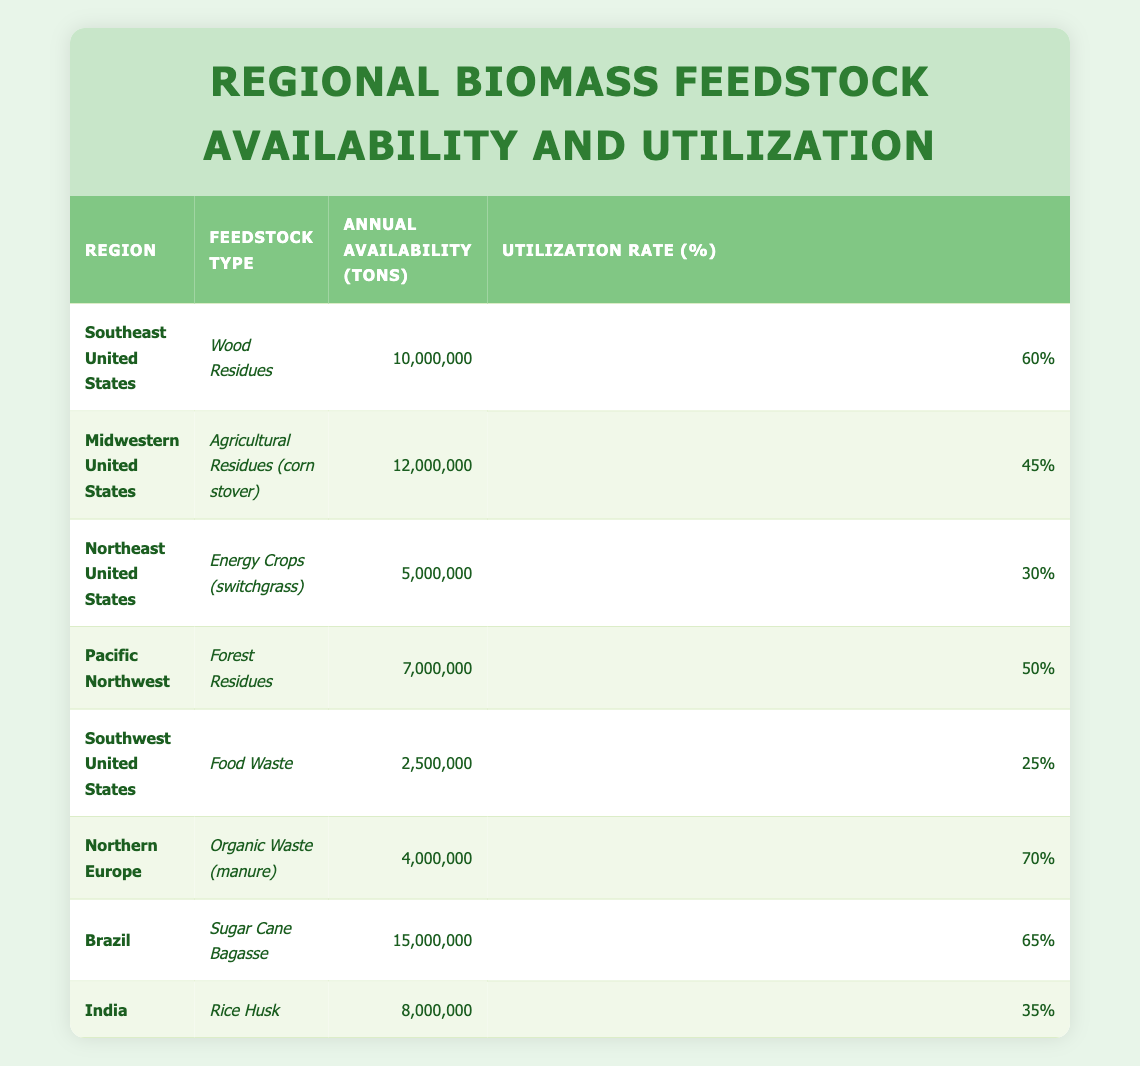What is the annual availability of biomass feedstock in the Southeast United States? The table indicates that the annual availability of biomass feedstock in the Southeast United States is listed as 10,000,000 tons.
Answer: 10,000,000 tons Which region has the highest utilization rate? By examining the table, Northern Europe has the highest utilization rate at 70%.
Answer: Northern Europe What is the total annual availability of biomass feedstock from all regions listed? To find the total, sum the annual availability from each region: 10,000,000 + 12,000,000 + 5,000,000 + 7,000,000 + 2,500,000 + 4,000,000 + 15,000,000 + 8,000,000 = 63,500,000 tons.
Answer: 63,500,000 tons Is the utilization rate for food waste higher than that for energy crops? The utilization rate for food waste (25%) is lower than that for energy crops (30%), thus the statement is false.
Answer: No What is the difference in annual availability between Brazil and the Northeast United States? The annual availability in Brazil is 15,000,000 tons, and in the Northeast United States, it is 5,000,000 tons. The difference is 15,000,000 - 5,000,000 = 10,000,000 tons.
Answer: 10,000,000 tons Which feedstock type has the lowest annual availability, and what is that amount? Looking at the table, food waste from the Southwest United States has the lowest availability at 2,500,000 tons.
Answer: Food waste, 2,500,000 tons What is the average utilization rate of biomass feedstock across all regions? To calculate the average utilization rate, sum the rates (60 + 45 + 30 + 50 + 25 + 70 + 65 + 35) = 410, then divide by the number of regions (8). So, 410/8 = 51.25%.
Answer: 51.25% Does India have a higher annual availability than the Pacific Northwest? India has an annual availability of 8,000,000 tons, while the Pacific Northwest has 7,000,000 tons. Therefore, this statement is true.
Answer: Yes 